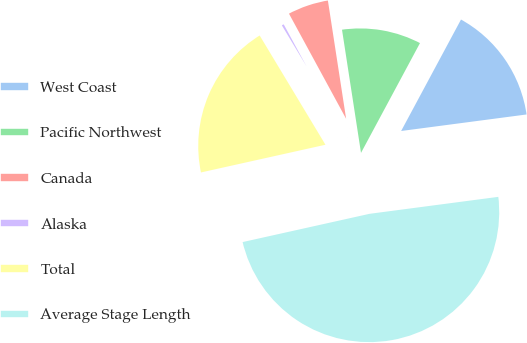Convert chart to OTSL. <chart><loc_0><loc_0><loc_500><loc_500><pie_chart><fcel>West Coast<fcel>Pacific Northwest<fcel>Canada<fcel>Alaska<fcel>Total<fcel>Average Stage Length<nl><fcel>15.07%<fcel>10.28%<fcel>5.49%<fcel>0.7%<fcel>19.86%<fcel>48.6%<nl></chart> 